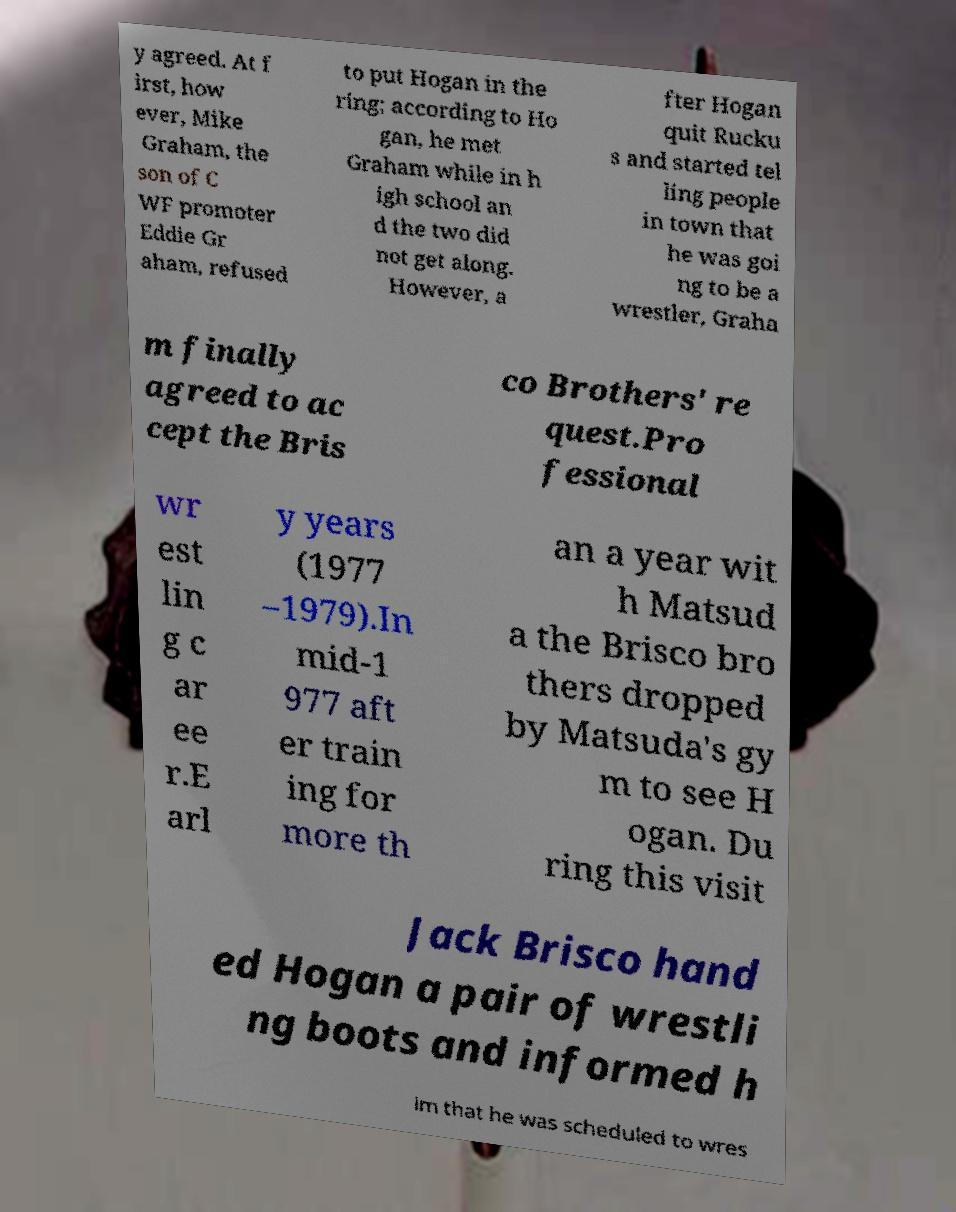There's text embedded in this image that I need extracted. Can you transcribe it verbatim? y agreed. At f irst, how ever, Mike Graham, the son of C WF promoter Eddie Gr aham, refused to put Hogan in the ring; according to Ho gan, he met Graham while in h igh school an d the two did not get along. However, a fter Hogan quit Rucku s and started tel ling people in town that he was goi ng to be a wrestler, Graha m finally agreed to ac cept the Bris co Brothers' re quest.Pro fessional wr est lin g c ar ee r.E arl y years (1977 –1979).In mid-1 977 aft er train ing for more th an a year wit h Matsud a the Brisco bro thers dropped by Matsuda's gy m to see H ogan. Du ring this visit Jack Brisco hand ed Hogan a pair of wrestli ng boots and informed h im that he was scheduled to wres 